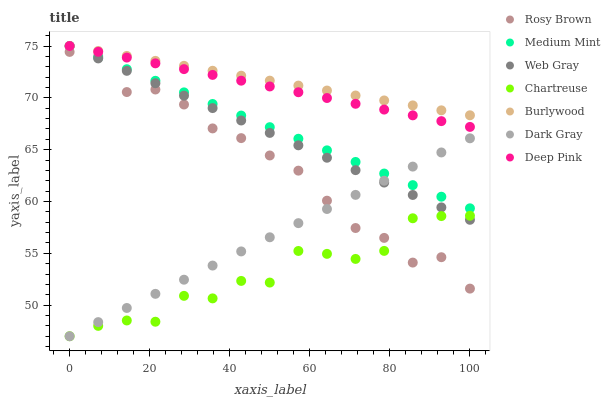Does Chartreuse have the minimum area under the curve?
Answer yes or no. Yes. Does Burlywood have the maximum area under the curve?
Answer yes or no. Yes. Does Web Gray have the minimum area under the curve?
Answer yes or no. No. Does Web Gray have the maximum area under the curve?
Answer yes or no. No. Is Dark Gray the smoothest?
Answer yes or no. Yes. Is Chartreuse the roughest?
Answer yes or no. Yes. Is Web Gray the smoothest?
Answer yes or no. No. Is Web Gray the roughest?
Answer yes or no. No. Does Dark Gray have the lowest value?
Answer yes or no. Yes. Does Web Gray have the lowest value?
Answer yes or no. No. Does Deep Pink have the highest value?
Answer yes or no. Yes. Does Rosy Brown have the highest value?
Answer yes or no. No. Is Chartreuse less than Deep Pink?
Answer yes or no. Yes. Is Burlywood greater than Chartreuse?
Answer yes or no. Yes. Does Medium Mint intersect Rosy Brown?
Answer yes or no. Yes. Is Medium Mint less than Rosy Brown?
Answer yes or no. No. Is Medium Mint greater than Rosy Brown?
Answer yes or no. No. Does Chartreuse intersect Deep Pink?
Answer yes or no. No. 